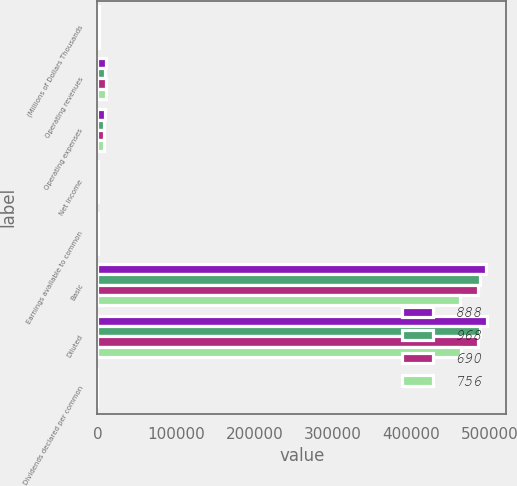Convert chart to OTSL. <chart><loc_0><loc_0><loc_500><loc_500><stacked_bar_chart><ecel><fcel>(Millions of Dollars Thousands<fcel>Operating revenues<fcel>Operating expenses<fcel>Net income<fcel>Earnings available to common<fcel>Basic<fcel>Diluted<fcel>Dividends declared per common<nl><fcel>888<fcel>2013<fcel>10915<fcel>9067<fcel>948<fcel>948<fcel>496073<fcel>496532<fcel>1.11<nl><fcel>968<fcel>2012<fcel>10128<fcel>8306<fcel>905<fcel>905<fcel>487899<fcel>488434<fcel>1.07<nl><fcel>690<fcel>2011<fcel>10655<fcel>8873<fcel>841<fcel>834<fcel>485039<fcel>485615<fcel>1.03<nl><fcel>756<fcel>2010<fcel>10311<fcel>8691<fcel>756<fcel>752<fcel>462052<fcel>463391<fcel>1<nl></chart> 